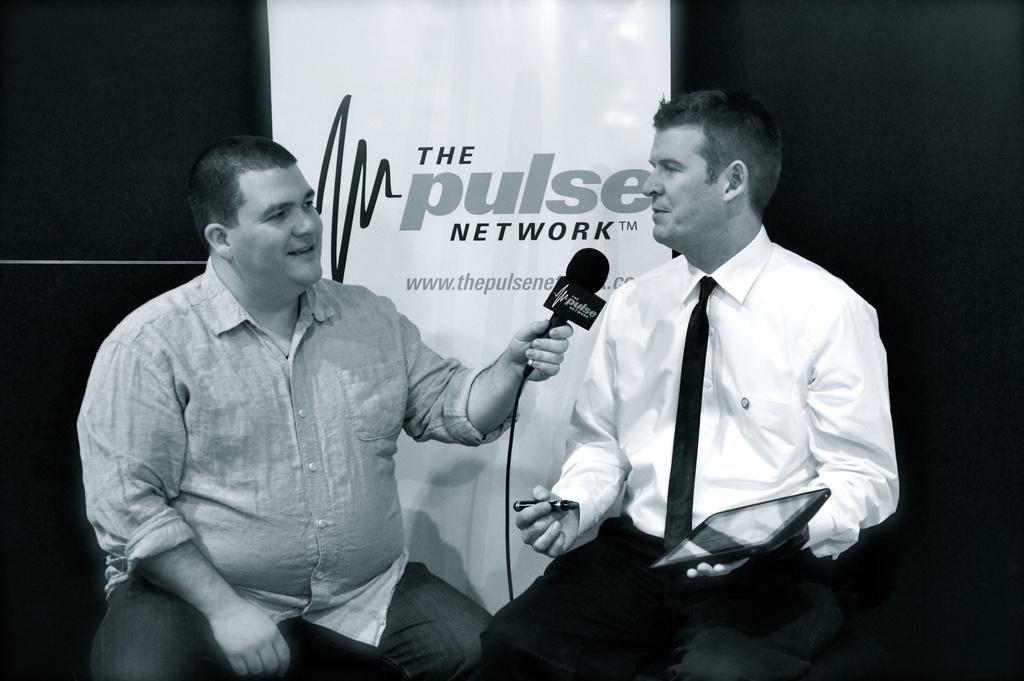How would you summarize this image in a sentence or two? In this image I see 2 men sitting and one of them is holding a mic and another one is holding an electronic device and a marker in his hands. In the background I see a board. 